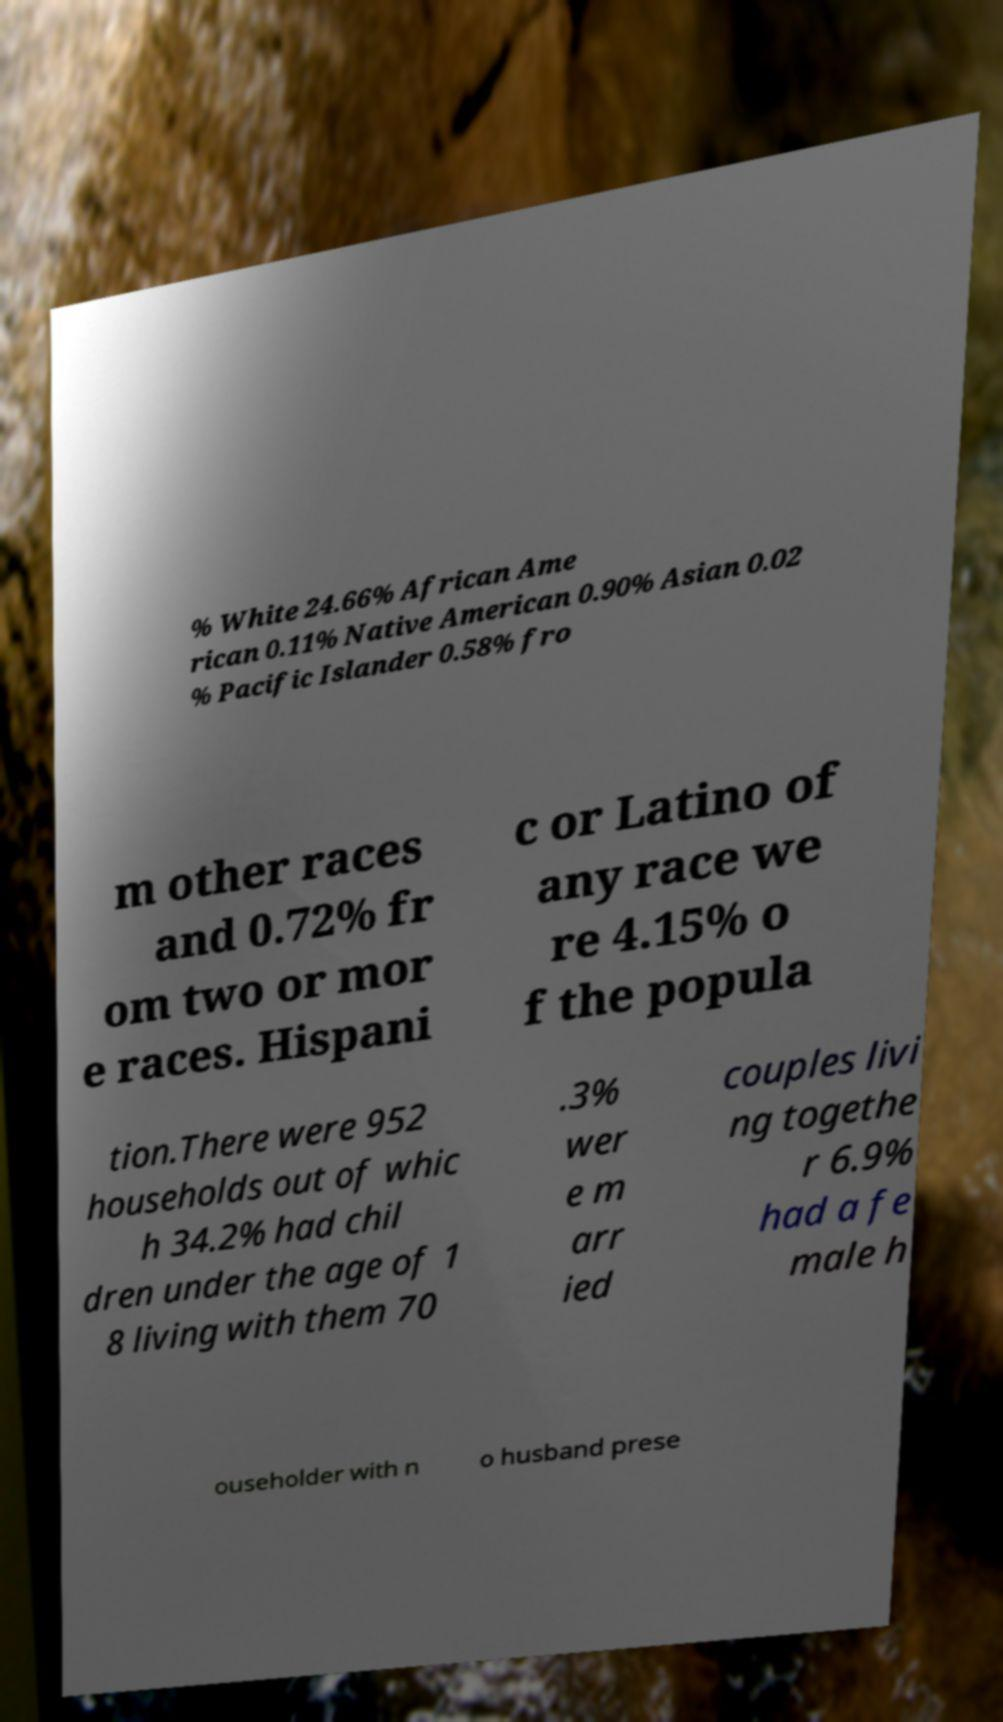Could you assist in decoding the text presented in this image and type it out clearly? % White 24.66% African Ame rican 0.11% Native American 0.90% Asian 0.02 % Pacific Islander 0.58% fro m other races and 0.72% fr om two or mor e races. Hispani c or Latino of any race we re 4.15% o f the popula tion.There were 952 households out of whic h 34.2% had chil dren under the age of 1 8 living with them 70 .3% wer e m arr ied couples livi ng togethe r 6.9% had a fe male h ouseholder with n o husband prese 